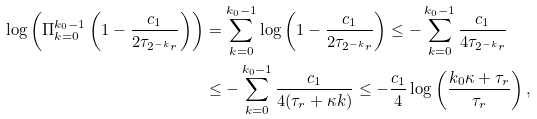<formula> <loc_0><loc_0><loc_500><loc_500>\log \left ( \Pi _ { k = 0 } ^ { k _ { 0 } - 1 } \left ( 1 - \frac { c _ { 1 } } { 2 \tau _ { 2 ^ { - k } r } } \right ) \right ) & = \sum _ { k = 0 } ^ { k _ { 0 } - 1 } \log \left ( 1 - \frac { c _ { 1 } } { 2 \tau _ { 2 ^ { - k } r } } \right ) \leq - \sum _ { k = 0 } ^ { k _ { 0 } - 1 } \frac { c _ { 1 } } { 4 \tau _ { 2 ^ { - k } r } } \\ & \leq - \sum _ { k = 0 } ^ { k _ { 0 } - 1 } \frac { c _ { 1 } } { 4 ( \tau _ { r } + \kappa k ) } \leq - \frac { c _ { 1 } } { 4 } \log \left ( \frac { k _ { 0 } \kappa + \tau _ { r } } { \tau _ { r } } \right ) ,</formula> 